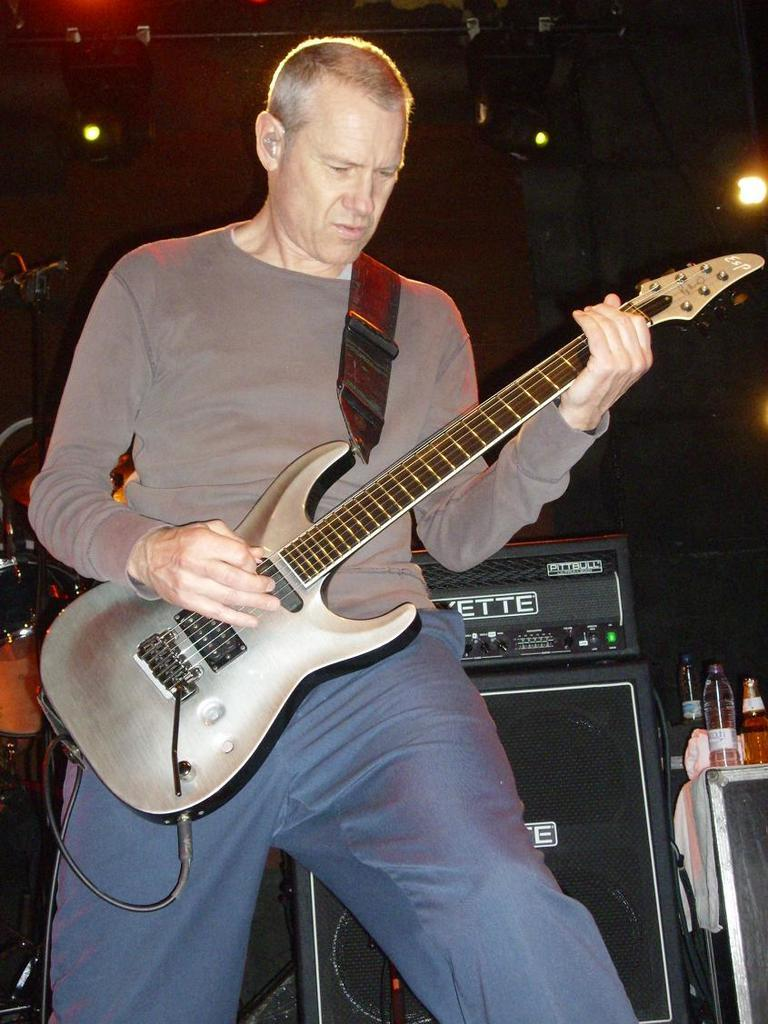Who is the main subject in the image? There is a man in the image. What is the man doing in the image? The man is playing a guitar. Where is the man located in the image? The man is on a stage. What type of string is used to make the quilt in the image? There is no quilt present in the image, so it is not possible to determine what type of string might be used. 